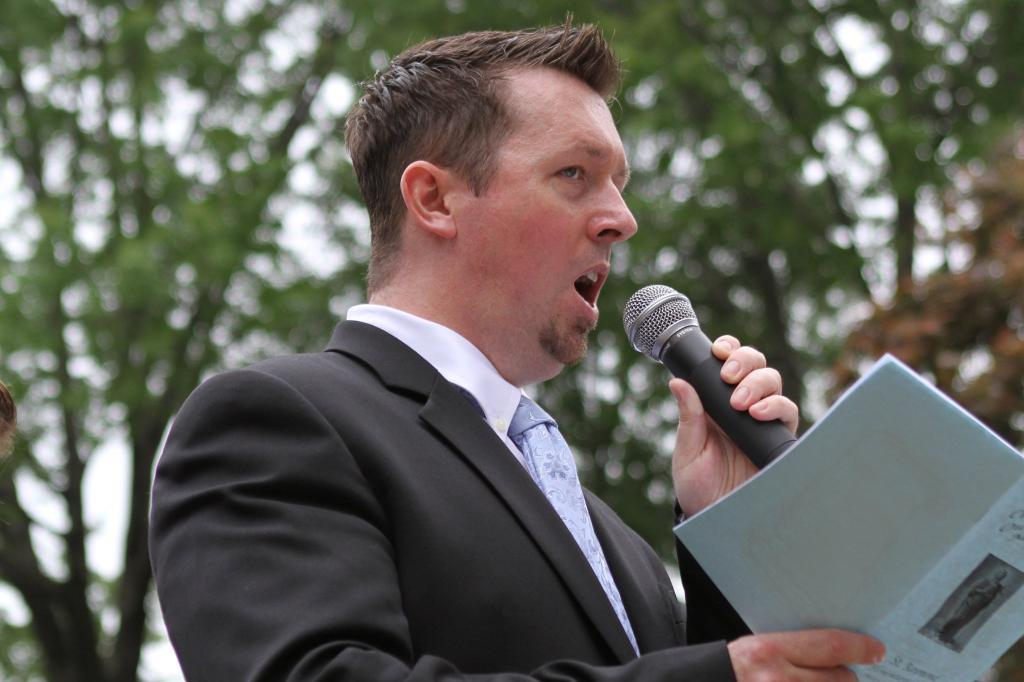What is the man in the image doing? The man in the image is speaking. What is the man holding in his hand? The man is holding a microphone in one hand and a book in the other hand. What is the man wearing? The man is wearing a black suit. What can be seen in the background of the image? There are trees in the background of the image. What type of skirt is the man wearing in the image? The man is not wearing a skirt in the image; he is wearing a black suit. What decision is the man making while holding the book in the image? There is no indication of a decision being made in the image; the man is simply holding a book and speaking into a microphone. 